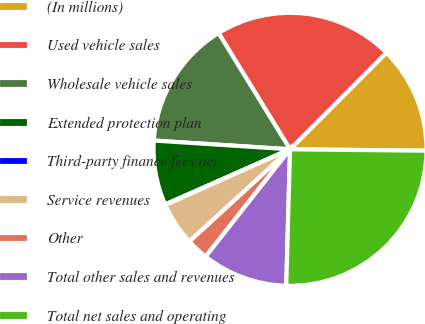<chart> <loc_0><loc_0><loc_500><loc_500><pie_chart><fcel>(In millions)<fcel>Used vehicle sales<fcel>Wholesale vehicle sales<fcel>Extended protection plan<fcel>Third-party finance fees net<fcel>Service revenues<fcel>Other<fcel>Total other sales and revenues<fcel>Total net sales and operating<nl><fcel>12.68%<fcel>21.26%<fcel>15.2%<fcel>7.64%<fcel>0.07%<fcel>5.12%<fcel>2.59%<fcel>10.16%<fcel>25.28%<nl></chart> 